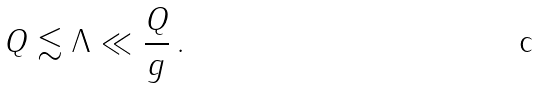<formula> <loc_0><loc_0><loc_500><loc_500>Q \lesssim \Lambda \ll \frac { Q } { g } \, .</formula> 